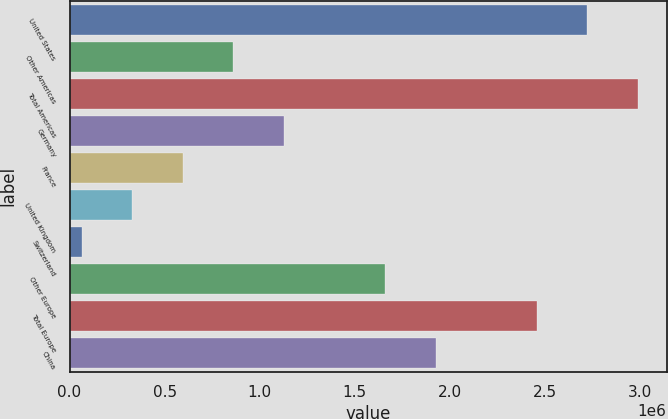Convert chart. <chart><loc_0><loc_0><loc_500><loc_500><bar_chart><fcel>United States<fcel>Other Americas<fcel>Total Americas<fcel>Germany<fcel>France<fcel>United Kingdom<fcel>Switzerland<fcel>Other Europe<fcel>Total Europe<fcel>China<nl><fcel>2.72505e+06<fcel>861679<fcel>2.99125e+06<fcel>1.12788e+06<fcel>595483<fcel>329286<fcel>63090<fcel>1.66027e+06<fcel>2.45886e+06<fcel>1.92646e+06<nl></chart> 